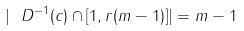Convert formula to latex. <formula><loc_0><loc_0><loc_500><loc_500>| \ D ^ { - 1 } ( c ) \cap [ 1 , r ( m - 1 ) ] | = m - 1</formula> 